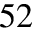Convert formula to latex. <formula><loc_0><loc_0><loc_500><loc_500>^ { 5 2 }</formula> 